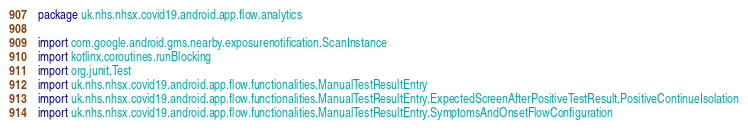Convert code to text. <code><loc_0><loc_0><loc_500><loc_500><_Kotlin_>package uk.nhs.nhsx.covid19.android.app.flow.analytics

import com.google.android.gms.nearby.exposurenotification.ScanInstance
import kotlinx.coroutines.runBlocking
import org.junit.Test
import uk.nhs.nhsx.covid19.android.app.flow.functionalities.ManualTestResultEntry
import uk.nhs.nhsx.covid19.android.app.flow.functionalities.ManualTestResultEntry.ExpectedScreenAfterPositiveTestResult.PositiveContinueIsolation
import uk.nhs.nhsx.covid19.android.app.flow.functionalities.ManualTestResultEntry.SymptomsAndOnsetFlowConfiguration</code> 